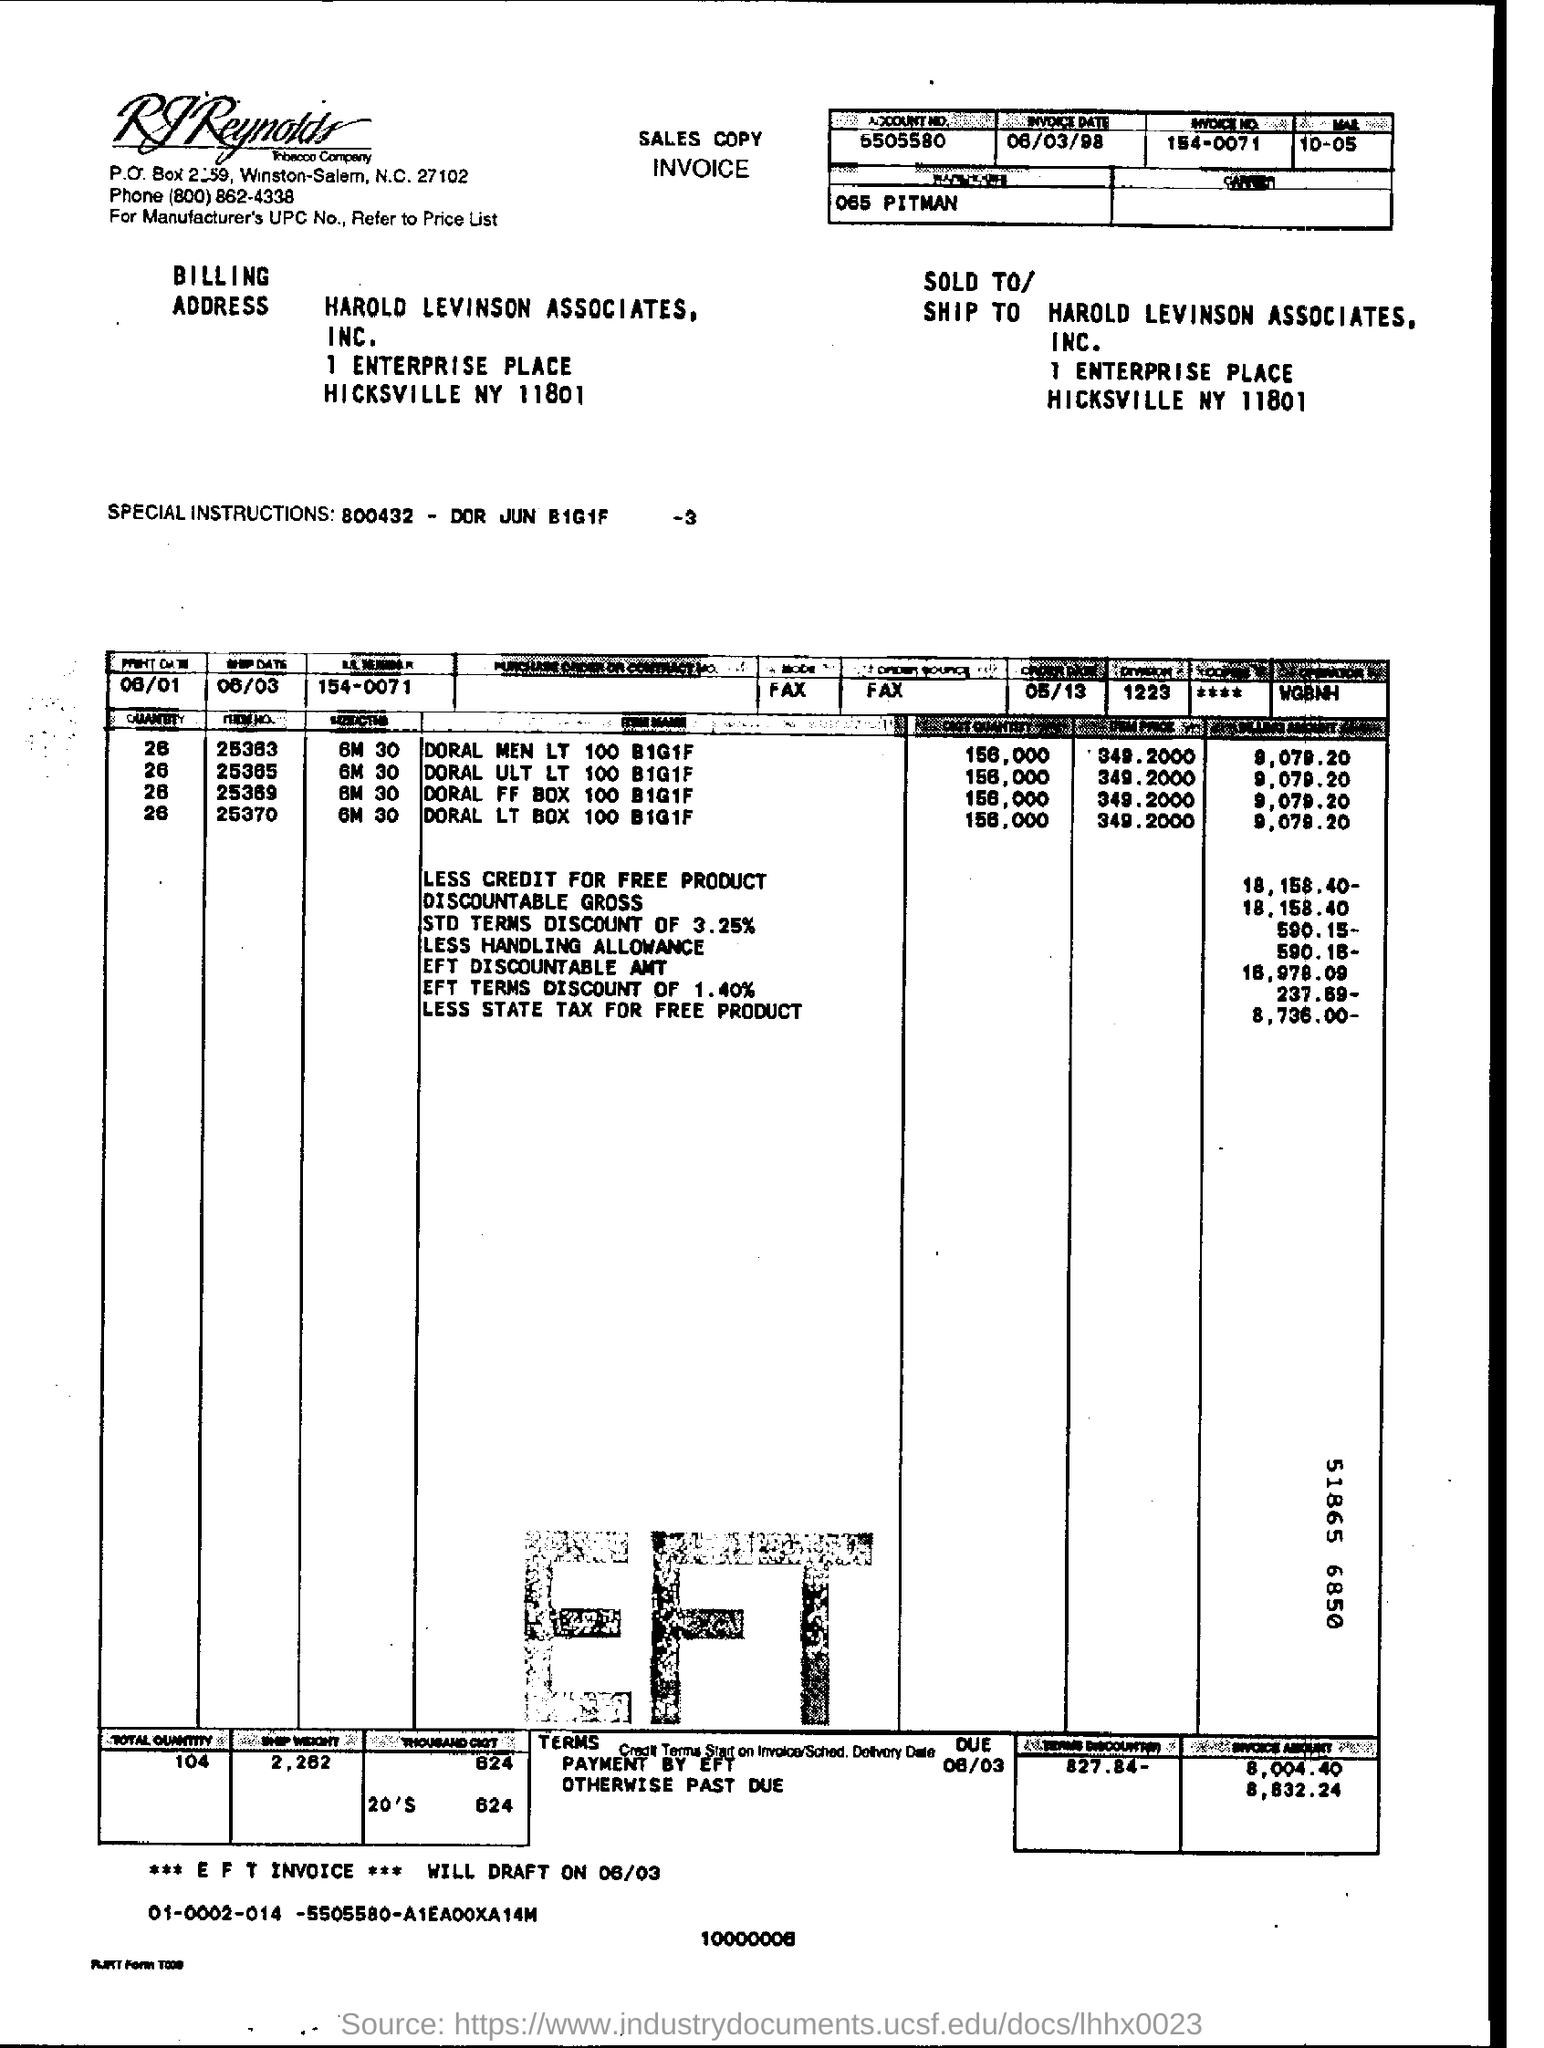what is the ***EFT INVOICE *** WILL DRAFT ON ?
 06/03 